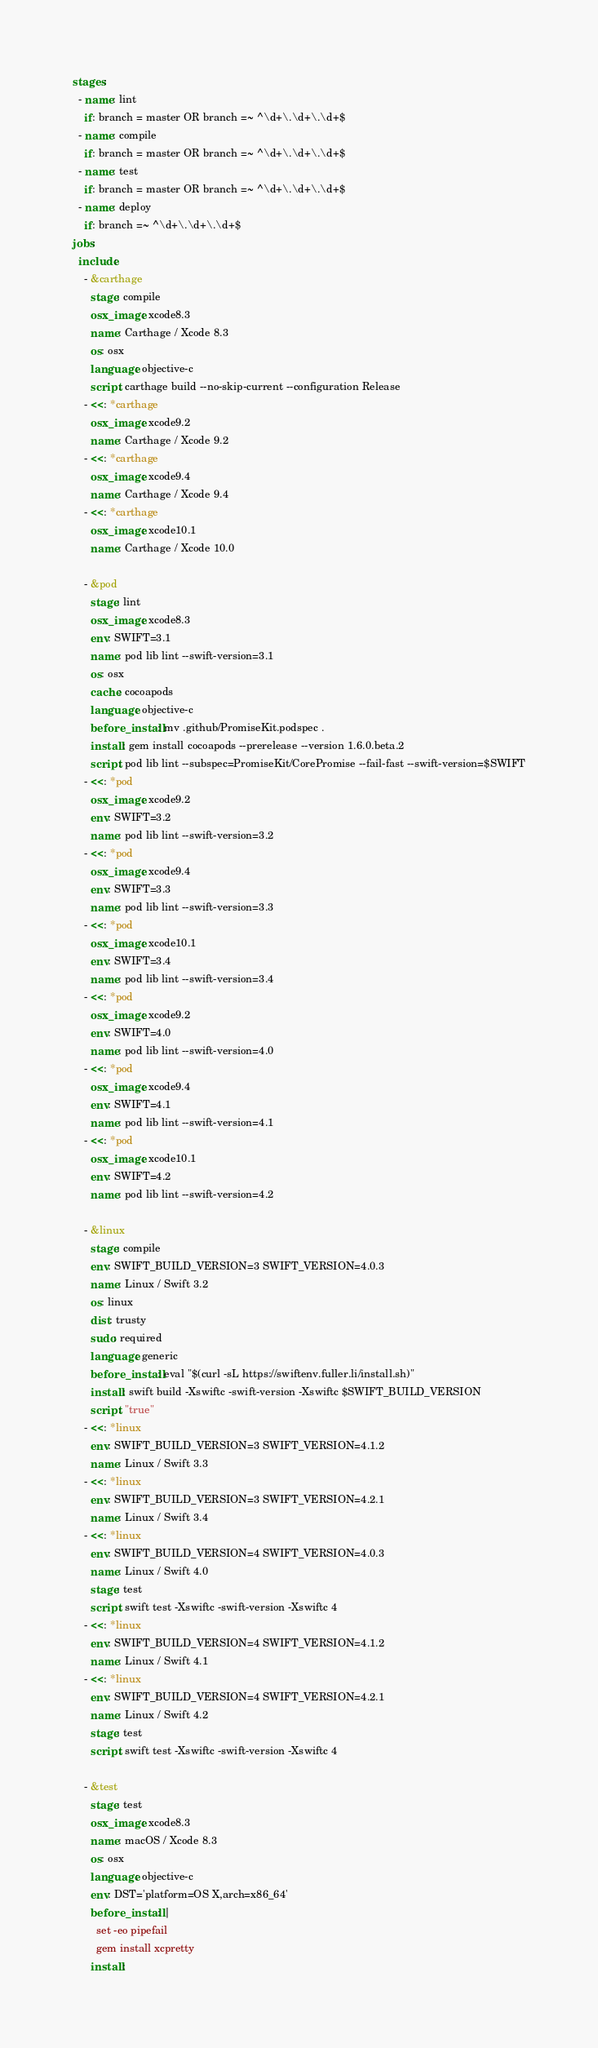Convert code to text. <code><loc_0><loc_0><loc_500><loc_500><_YAML_>stages:
  - name: lint
    if: branch = master OR branch =~ ^\d+\.\d+\.\d+$
  - name: compile
    if: branch = master OR branch =~ ^\d+\.\d+\.\d+$
  - name: test
    if: branch = master OR branch =~ ^\d+\.\d+\.\d+$
  - name: deploy
    if: branch =~ ^\d+\.\d+\.\d+$
jobs:
  include:
    - &carthage
      stage: compile
      osx_image: xcode8.3
      name: Carthage / Xcode 8.3
      os: osx
      language: objective-c
      script: carthage build --no-skip-current --configuration Release
    - <<: *carthage
      osx_image: xcode9.2
      name: Carthage / Xcode 9.2
    - <<: *carthage
      osx_image: xcode9.4
      name: Carthage / Xcode 9.4
    - <<: *carthage
      osx_image: xcode10.1
      name: Carthage / Xcode 10.0

    - &pod
      stage: lint
      osx_image: xcode8.3
      env: SWIFT=3.1
      name: pod lib lint --swift-version=3.1
      os: osx
      cache: cocoapods
      language: objective-c
      before_install: mv .github/PromiseKit.podspec .
      install: gem install cocoapods --prerelease --version 1.6.0.beta.2
      script: pod lib lint --subspec=PromiseKit/CorePromise --fail-fast --swift-version=$SWIFT
    - <<: *pod
      osx_image: xcode9.2
      env: SWIFT=3.2
      name: pod lib lint --swift-version=3.2
    - <<: *pod
      osx_image: xcode9.4
      env: SWIFT=3.3
      name: pod lib lint --swift-version=3.3
    - <<: *pod
      osx_image: xcode10.1
      env: SWIFT=3.4
      name: pod lib lint --swift-version=3.4
    - <<: *pod
      osx_image: xcode9.2
      env: SWIFT=4.0
      name: pod lib lint --swift-version=4.0
    - <<: *pod
      osx_image: xcode9.4
      env: SWIFT=4.1
      name: pod lib lint --swift-version=4.1
    - <<: *pod
      osx_image: xcode10.1
      env: SWIFT=4.2
      name: pod lib lint --swift-version=4.2

    - &linux
      stage: compile
      env: SWIFT_BUILD_VERSION=3 SWIFT_VERSION=4.0.3
      name: Linux / Swift 3.2
      os: linux
      dist: trusty
      sudo: required
      language: generic
      before_install: eval "$(curl -sL https://swiftenv.fuller.li/install.sh)"
      install: swift build -Xswiftc -swift-version -Xswiftc $SWIFT_BUILD_VERSION
      script: "true"
    - <<: *linux
      env: SWIFT_BUILD_VERSION=3 SWIFT_VERSION=4.1.2
      name: Linux / Swift 3.3
    - <<: *linux
      env: SWIFT_BUILD_VERSION=3 SWIFT_VERSION=4.2.1
      name: Linux / Swift 3.4
    - <<: *linux
      env: SWIFT_BUILD_VERSION=4 SWIFT_VERSION=4.0.3
      name: Linux / Swift 4.0
      stage: test
      script: swift test -Xswiftc -swift-version -Xswiftc 4
    - <<: *linux
      env: SWIFT_BUILD_VERSION=4 SWIFT_VERSION=4.1.2
      name: Linux / Swift 4.1
    - <<: *linux
      env: SWIFT_BUILD_VERSION=4 SWIFT_VERSION=4.2.1
      name: Linux / Swift 4.2
      stage: test
      script: swift test -Xswiftc -swift-version -Xswiftc 4

    - &test
      stage: test
      osx_image: xcode8.3
      name: macOS / Xcode 8.3
      os: osx
      language: objective-c
      env: DST='platform=OS X,arch=x86_64'
      before_install: |
        set -eo pipefail
        gem install xcpretty
      install:</code> 